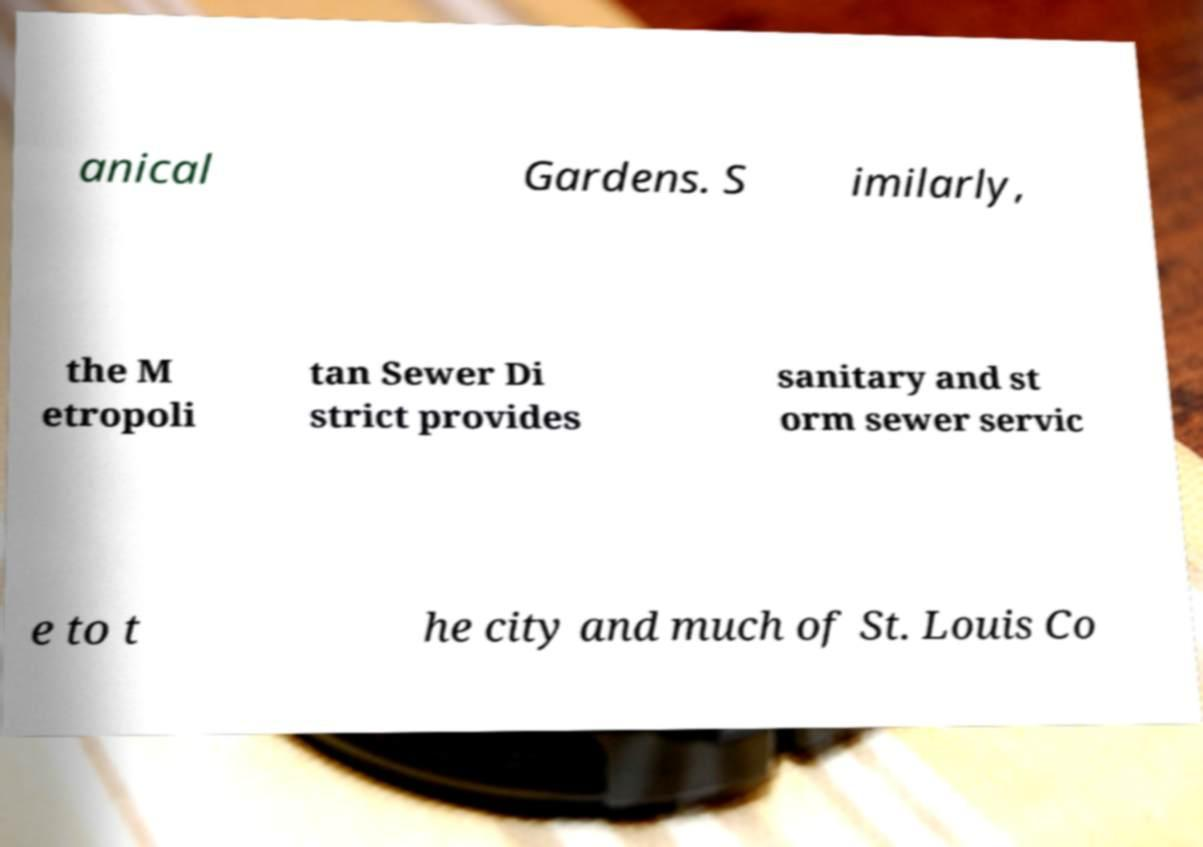Please identify and transcribe the text found in this image. anical Gardens. S imilarly, the M etropoli tan Sewer Di strict provides sanitary and st orm sewer servic e to t he city and much of St. Louis Co 